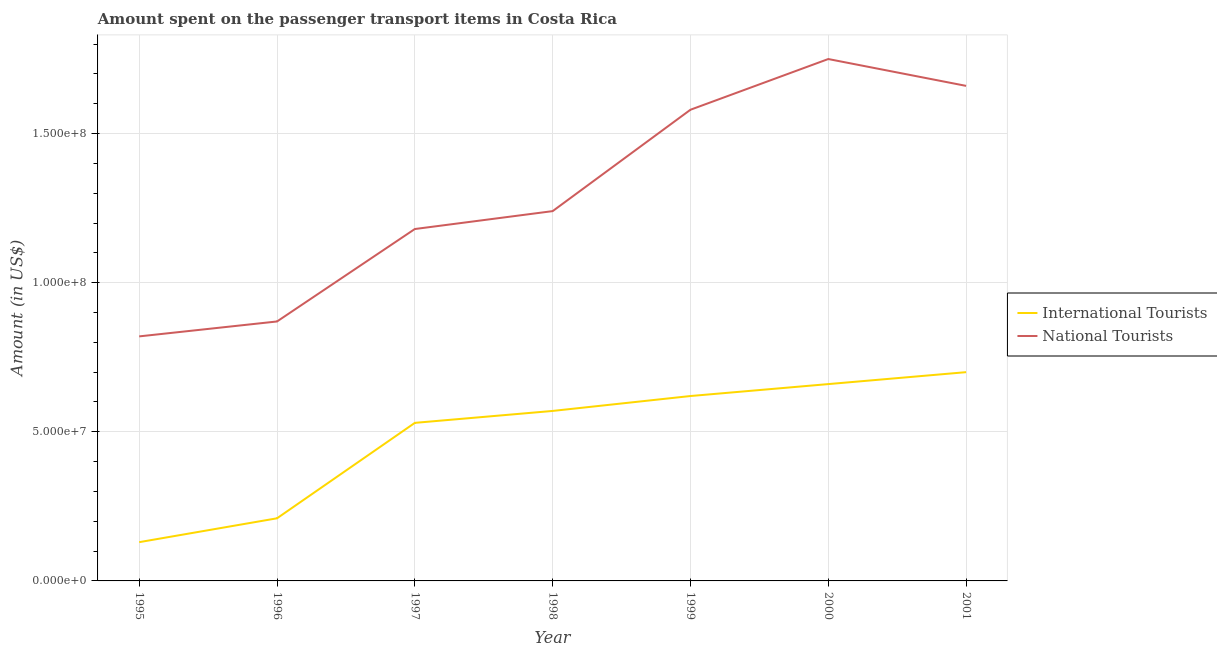Is the number of lines equal to the number of legend labels?
Ensure brevity in your answer.  Yes. What is the amount spent on transport items of national tourists in 2000?
Ensure brevity in your answer.  1.75e+08. Across all years, what is the maximum amount spent on transport items of international tourists?
Give a very brief answer. 7.00e+07. Across all years, what is the minimum amount spent on transport items of national tourists?
Offer a terse response. 8.20e+07. In which year was the amount spent on transport items of international tourists maximum?
Make the answer very short. 2001. What is the total amount spent on transport items of national tourists in the graph?
Give a very brief answer. 9.10e+08. What is the difference between the amount spent on transport items of national tourists in 1999 and that in 2000?
Your response must be concise. -1.70e+07. What is the difference between the amount spent on transport items of international tourists in 2001 and the amount spent on transport items of national tourists in 1995?
Offer a terse response. -1.20e+07. What is the average amount spent on transport items of national tourists per year?
Your response must be concise. 1.30e+08. In the year 1998, what is the difference between the amount spent on transport items of international tourists and amount spent on transport items of national tourists?
Your answer should be very brief. -6.70e+07. In how many years, is the amount spent on transport items of international tourists greater than 150000000 US$?
Keep it short and to the point. 0. What is the ratio of the amount spent on transport items of national tourists in 2000 to that in 2001?
Provide a succinct answer. 1.05. What is the difference between the highest and the lowest amount spent on transport items of national tourists?
Keep it short and to the point. 9.30e+07. Is the sum of the amount spent on transport items of international tourists in 1999 and 2001 greater than the maximum amount spent on transport items of national tourists across all years?
Keep it short and to the point. No. Is the amount spent on transport items of national tourists strictly greater than the amount spent on transport items of international tourists over the years?
Make the answer very short. Yes. Is the amount spent on transport items of national tourists strictly less than the amount spent on transport items of international tourists over the years?
Your answer should be very brief. No. How many lines are there?
Keep it short and to the point. 2. Does the graph contain grids?
Offer a terse response. Yes. How many legend labels are there?
Keep it short and to the point. 2. How are the legend labels stacked?
Keep it short and to the point. Vertical. What is the title of the graph?
Offer a terse response. Amount spent on the passenger transport items in Costa Rica. What is the label or title of the X-axis?
Give a very brief answer. Year. What is the label or title of the Y-axis?
Offer a terse response. Amount (in US$). What is the Amount (in US$) of International Tourists in 1995?
Your answer should be compact. 1.30e+07. What is the Amount (in US$) of National Tourists in 1995?
Offer a very short reply. 8.20e+07. What is the Amount (in US$) in International Tourists in 1996?
Give a very brief answer. 2.10e+07. What is the Amount (in US$) of National Tourists in 1996?
Offer a very short reply. 8.70e+07. What is the Amount (in US$) in International Tourists in 1997?
Offer a terse response. 5.30e+07. What is the Amount (in US$) of National Tourists in 1997?
Ensure brevity in your answer.  1.18e+08. What is the Amount (in US$) of International Tourists in 1998?
Provide a short and direct response. 5.70e+07. What is the Amount (in US$) in National Tourists in 1998?
Provide a short and direct response. 1.24e+08. What is the Amount (in US$) of International Tourists in 1999?
Give a very brief answer. 6.20e+07. What is the Amount (in US$) in National Tourists in 1999?
Provide a short and direct response. 1.58e+08. What is the Amount (in US$) of International Tourists in 2000?
Ensure brevity in your answer.  6.60e+07. What is the Amount (in US$) of National Tourists in 2000?
Your answer should be very brief. 1.75e+08. What is the Amount (in US$) in International Tourists in 2001?
Offer a very short reply. 7.00e+07. What is the Amount (in US$) in National Tourists in 2001?
Provide a succinct answer. 1.66e+08. Across all years, what is the maximum Amount (in US$) of International Tourists?
Offer a very short reply. 7.00e+07. Across all years, what is the maximum Amount (in US$) of National Tourists?
Your answer should be very brief. 1.75e+08. Across all years, what is the minimum Amount (in US$) of International Tourists?
Provide a succinct answer. 1.30e+07. Across all years, what is the minimum Amount (in US$) in National Tourists?
Offer a terse response. 8.20e+07. What is the total Amount (in US$) of International Tourists in the graph?
Offer a very short reply. 3.42e+08. What is the total Amount (in US$) of National Tourists in the graph?
Offer a terse response. 9.10e+08. What is the difference between the Amount (in US$) of International Tourists in 1995 and that in 1996?
Your answer should be very brief. -8.00e+06. What is the difference between the Amount (in US$) of National Tourists in 1995 and that in 1996?
Ensure brevity in your answer.  -5.00e+06. What is the difference between the Amount (in US$) in International Tourists in 1995 and that in 1997?
Give a very brief answer. -4.00e+07. What is the difference between the Amount (in US$) of National Tourists in 1995 and that in 1997?
Your answer should be compact. -3.60e+07. What is the difference between the Amount (in US$) in International Tourists in 1995 and that in 1998?
Provide a short and direct response. -4.40e+07. What is the difference between the Amount (in US$) of National Tourists in 1995 and that in 1998?
Offer a very short reply. -4.20e+07. What is the difference between the Amount (in US$) in International Tourists in 1995 and that in 1999?
Ensure brevity in your answer.  -4.90e+07. What is the difference between the Amount (in US$) of National Tourists in 1995 and that in 1999?
Provide a succinct answer. -7.60e+07. What is the difference between the Amount (in US$) of International Tourists in 1995 and that in 2000?
Keep it short and to the point. -5.30e+07. What is the difference between the Amount (in US$) of National Tourists in 1995 and that in 2000?
Offer a very short reply. -9.30e+07. What is the difference between the Amount (in US$) of International Tourists in 1995 and that in 2001?
Your answer should be very brief. -5.70e+07. What is the difference between the Amount (in US$) of National Tourists in 1995 and that in 2001?
Keep it short and to the point. -8.40e+07. What is the difference between the Amount (in US$) of International Tourists in 1996 and that in 1997?
Make the answer very short. -3.20e+07. What is the difference between the Amount (in US$) of National Tourists in 1996 and that in 1997?
Your answer should be very brief. -3.10e+07. What is the difference between the Amount (in US$) of International Tourists in 1996 and that in 1998?
Your response must be concise. -3.60e+07. What is the difference between the Amount (in US$) in National Tourists in 1996 and that in 1998?
Your answer should be very brief. -3.70e+07. What is the difference between the Amount (in US$) of International Tourists in 1996 and that in 1999?
Provide a short and direct response. -4.10e+07. What is the difference between the Amount (in US$) in National Tourists in 1996 and that in 1999?
Your answer should be compact. -7.10e+07. What is the difference between the Amount (in US$) in International Tourists in 1996 and that in 2000?
Provide a short and direct response. -4.50e+07. What is the difference between the Amount (in US$) in National Tourists in 1996 and that in 2000?
Provide a succinct answer. -8.80e+07. What is the difference between the Amount (in US$) in International Tourists in 1996 and that in 2001?
Make the answer very short. -4.90e+07. What is the difference between the Amount (in US$) in National Tourists in 1996 and that in 2001?
Provide a succinct answer. -7.90e+07. What is the difference between the Amount (in US$) of National Tourists in 1997 and that in 1998?
Make the answer very short. -6.00e+06. What is the difference between the Amount (in US$) in International Tourists in 1997 and that in 1999?
Ensure brevity in your answer.  -9.00e+06. What is the difference between the Amount (in US$) in National Tourists in 1997 and that in 1999?
Offer a terse response. -4.00e+07. What is the difference between the Amount (in US$) in International Tourists in 1997 and that in 2000?
Offer a very short reply. -1.30e+07. What is the difference between the Amount (in US$) in National Tourists in 1997 and that in 2000?
Your response must be concise. -5.70e+07. What is the difference between the Amount (in US$) of International Tourists in 1997 and that in 2001?
Provide a short and direct response. -1.70e+07. What is the difference between the Amount (in US$) of National Tourists in 1997 and that in 2001?
Your answer should be compact. -4.80e+07. What is the difference between the Amount (in US$) of International Tourists in 1998 and that in 1999?
Keep it short and to the point. -5.00e+06. What is the difference between the Amount (in US$) of National Tourists in 1998 and that in 1999?
Your answer should be very brief. -3.40e+07. What is the difference between the Amount (in US$) of International Tourists in 1998 and that in 2000?
Ensure brevity in your answer.  -9.00e+06. What is the difference between the Amount (in US$) of National Tourists in 1998 and that in 2000?
Provide a short and direct response. -5.10e+07. What is the difference between the Amount (in US$) in International Tourists in 1998 and that in 2001?
Your answer should be compact. -1.30e+07. What is the difference between the Amount (in US$) of National Tourists in 1998 and that in 2001?
Provide a short and direct response. -4.20e+07. What is the difference between the Amount (in US$) in National Tourists in 1999 and that in 2000?
Provide a succinct answer. -1.70e+07. What is the difference between the Amount (in US$) in International Tourists in 1999 and that in 2001?
Your answer should be very brief. -8.00e+06. What is the difference between the Amount (in US$) of National Tourists in 1999 and that in 2001?
Ensure brevity in your answer.  -8.00e+06. What is the difference between the Amount (in US$) of National Tourists in 2000 and that in 2001?
Keep it short and to the point. 9.00e+06. What is the difference between the Amount (in US$) of International Tourists in 1995 and the Amount (in US$) of National Tourists in 1996?
Ensure brevity in your answer.  -7.40e+07. What is the difference between the Amount (in US$) in International Tourists in 1995 and the Amount (in US$) in National Tourists in 1997?
Provide a short and direct response. -1.05e+08. What is the difference between the Amount (in US$) in International Tourists in 1995 and the Amount (in US$) in National Tourists in 1998?
Offer a terse response. -1.11e+08. What is the difference between the Amount (in US$) of International Tourists in 1995 and the Amount (in US$) of National Tourists in 1999?
Provide a succinct answer. -1.45e+08. What is the difference between the Amount (in US$) in International Tourists in 1995 and the Amount (in US$) in National Tourists in 2000?
Provide a succinct answer. -1.62e+08. What is the difference between the Amount (in US$) in International Tourists in 1995 and the Amount (in US$) in National Tourists in 2001?
Provide a succinct answer. -1.53e+08. What is the difference between the Amount (in US$) in International Tourists in 1996 and the Amount (in US$) in National Tourists in 1997?
Provide a succinct answer. -9.70e+07. What is the difference between the Amount (in US$) of International Tourists in 1996 and the Amount (in US$) of National Tourists in 1998?
Your answer should be compact. -1.03e+08. What is the difference between the Amount (in US$) of International Tourists in 1996 and the Amount (in US$) of National Tourists in 1999?
Your answer should be compact. -1.37e+08. What is the difference between the Amount (in US$) in International Tourists in 1996 and the Amount (in US$) in National Tourists in 2000?
Keep it short and to the point. -1.54e+08. What is the difference between the Amount (in US$) of International Tourists in 1996 and the Amount (in US$) of National Tourists in 2001?
Your answer should be compact. -1.45e+08. What is the difference between the Amount (in US$) of International Tourists in 1997 and the Amount (in US$) of National Tourists in 1998?
Your answer should be very brief. -7.10e+07. What is the difference between the Amount (in US$) in International Tourists in 1997 and the Amount (in US$) in National Tourists in 1999?
Give a very brief answer. -1.05e+08. What is the difference between the Amount (in US$) in International Tourists in 1997 and the Amount (in US$) in National Tourists in 2000?
Your response must be concise. -1.22e+08. What is the difference between the Amount (in US$) in International Tourists in 1997 and the Amount (in US$) in National Tourists in 2001?
Ensure brevity in your answer.  -1.13e+08. What is the difference between the Amount (in US$) in International Tourists in 1998 and the Amount (in US$) in National Tourists in 1999?
Give a very brief answer. -1.01e+08. What is the difference between the Amount (in US$) in International Tourists in 1998 and the Amount (in US$) in National Tourists in 2000?
Provide a succinct answer. -1.18e+08. What is the difference between the Amount (in US$) of International Tourists in 1998 and the Amount (in US$) of National Tourists in 2001?
Keep it short and to the point. -1.09e+08. What is the difference between the Amount (in US$) in International Tourists in 1999 and the Amount (in US$) in National Tourists in 2000?
Your answer should be very brief. -1.13e+08. What is the difference between the Amount (in US$) in International Tourists in 1999 and the Amount (in US$) in National Tourists in 2001?
Give a very brief answer. -1.04e+08. What is the difference between the Amount (in US$) in International Tourists in 2000 and the Amount (in US$) in National Tourists in 2001?
Offer a terse response. -1.00e+08. What is the average Amount (in US$) of International Tourists per year?
Offer a terse response. 4.89e+07. What is the average Amount (in US$) in National Tourists per year?
Ensure brevity in your answer.  1.30e+08. In the year 1995, what is the difference between the Amount (in US$) of International Tourists and Amount (in US$) of National Tourists?
Keep it short and to the point. -6.90e+07. In the year 1996, what is the difference between the Amount (in US$) of International Tourists and Amount (in US$) of National Tourists?
Give a very brief answer. -6.60e+07. In the year 1997, what is the difference between the Amount (in US$) in International Tourists and Amount (in US$) in National Tourists?
Make the answer very short. -6.50e+07. In the year 1998, what is the difference between the Amount (in US$) of International Tourists and Amount (in US$) of National Tourists?
Provide a succinct answer. -6.70e+07. In the year 1999, what is the difference between the Amount (in US$) in International Tourists and Amount (in US$) in National Tourists?
Your answer should be very brief. -9.60e+07. In the year 2000, what is the difference between the Amount (in US$) in International Tourists and Amount (in US$) in National Tourists?
Your answer should be very brief. -1.09e+08. In the year 2001, what is the difference between the Amount (in US$) of International Tourists and Amount (in US$) of National Tourists?
Make the answer very short. -9.60e+07. What is the ratio of the Amount (in US$) of International Tourists in 1995 to that in 1996?
Provide a short and direct response. 0.62. What is the ratio of the Amount (in US$) of National Tourists in 1995 to that in 1996?
Make the answer very short. 0.94. What is the ratio of the Amount (in US$) in International Tourists in 1995 to that in 1997?
Give a very brief answer. 0.25. What is the ratio of the Amount (in US$) of National Tourists in 1995 to that in 1997?
Keep it short and to the point. 0.69. What is the ratio of the Amount (in US$) of International Tourists in 1995 to that in 1998?
Provide a succinct answer. 0.23. What is the ratio of the Amount (in US$) in National Tourists in 1995 to that in 1998?
Keep it short and to the point. 0.66. What is the ratio of the Amount (in US$) in International Tourists in 1995 to that in 1999?
Make the answer very short. 0.21. What is the ratio of the Amount (in US$) in National Tourists in 1995 to that in 1999?
Ensure brevity in your answer.  0.52. What is the ratio of the Amount (in US$) in International Tourists in 1995 to that in 2000?
Ensure brevity in your answer.  0.2. What is the ratio of the Amount (in US$) of National Tourists in 1995 to that in 2000?
Your answer should be very brief. 0.47. What is the ratio of the Amount (in US$) in International Tourists in 1995 to that in 2001?
Offer a very short reply. 0.19. What is the ratio of the Amount (in US$) of National Tourists in 1995 to that in 2001?
Offer a very short reply. 0.49. What is the ratio of the Amount (in US$) of International Tourists in 1996 to that in 1997?
Your response must be concise. 0.4. What is the ratio of the Amount (in US$) in National Tourists in 1996 to that in 1997?
Keep it short and to the point. 0.74. What is the ratio of the Amount (in US$) of International Tourists in 1996 to that in 1998?
Offer a very short reply. 0.37. What is the ratio of the Amount (in US$) in National Tourists in 1996 to that in 1998?
Your answer should be very brief. 0.7. What is the ratio of the Amount (in US$) in International Tourists in 1996 to that in 1999?
Your answer should be compact. 0.34. What is the ratio of the Amount (in US$) of National Tourists in 1996 to that in 1999?
Your answer should be compact. 0.55. What is the ratio of the Amount (in US$) in International Tourists in 1996 to that in 2000?
Give a very brief answer. 0.32. What is the ratio of the Amount (in US$) in National Tourists in 1996 to that in 2000?
Keep it short and to the point. 0.5. What is the ratio of the Amount (in US$) in International Tourists in 1996 to that in 2001?
Provide a short and direct response. 0.3. What is the ratio of the Amount (in US$) of National Tourists in 1996 to that in 2001?
Offer a terse response. 0.52. What is the ratio of the Amount (in US$) in International Tourists in 1997 to that in 1998?
Provide a short and direct response. 0.93. What is the ratio of the Amount (in US$) of National Tourists in 1997 to that in 1998?
Keep it short and to the point. 0.95. What is the ratio of the Amount (in US$) of International Tourists in 1997 to that in 1999?
Provide a succinct answer. 0.85. What is the ratio of the Amount (in US$) in National Tourists in 1997 to that in 1999?
Provide a short and direct response. 0.75. What is the ratio of the Amount (in US$) in International Tourists in 1997 to that in 2000?
Provide a short and direct response. 0.8. What is the ratio of the Amount (in US$) in National Tourists in 1997 to that in 2000?
Your response must be concise. 0.67. What is the ratio of the Amount (in US$) of International Tourists in 1997 to that in 2001?
Offer a terse response. 0.76. What is the ratio of the Amount (in US$) of National Tourists in 1997 to that in 2001?
Provide a short and direct response. 0.71. What is the ratio of the Amount (in US$) in International Tourists in 1998 to that in 1999?
Provide a short and direct response. 0.92. What is the ratio of the Amount (in US$) of National Tourists in 1998 to that in 1999?
Your response must be concise. 0.78. What is the ratio of the Amount (in US$) of International Tourists in 1998 to that in 2000?
Give a very brief answer. 0.86. What is the ratio of the Amount (in US$) of National Tourists in 1998 to that in 2000?
Provide a succinct answer. 0.71. What is the ratio of the Amount (in US$) in International Tourists in 1998 to that in 2001?
Ensure brevity in your answer.  0.81. What is the ratio of the Amount (in US$) of National Tourists in 1998 to that in 2001?
Your answer should be very brief. 0.75. What is the ratio of the Amount (in US$) in International Tourists in 1999 to that in 2000?
Make the answer very short. 0.94. What is the ratio of the Amount (in US$) in National Tourists in 1999 to that in 2000?
Provide a succinct answer. 0.9. What is the ratio of the Amount (in US$) in International Tourists in 1999 to that in 2001?
Give a very brief answer. 0.89. What is the ratio of the Amount (in US$) in National Tourists in 1999 to that in 2001?
Give a very brief answer. 0.95. What is the ratio of the Amount (in US$) of International Tourists in 2000 to that in 2001?
Provide a succinct answer. 0.94. What is the ratio of the Amount (in US$) of National Tourists in 2000 to that in 2001?
Offer a very short reply. 1.05. What is the difference between the highest and the second highest Amount (in US$) in National Tourists?
Make the answer very short. 9.00e+06. What is the difference between the highest and the lowest Amount (in US$) in International Tourists?
Your answer should be very brief. 5.70e+07. What is the difference between the highest and the lowest Amount (in US$) in National Tourists?
Make the answer very short. 9.30e+07. 